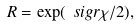Convert formula to latex. <formula><loc_0><loc_0><loc_500><loc_500>R = \exp ( \ s i g r \chi / 2 ) ,</formula> 